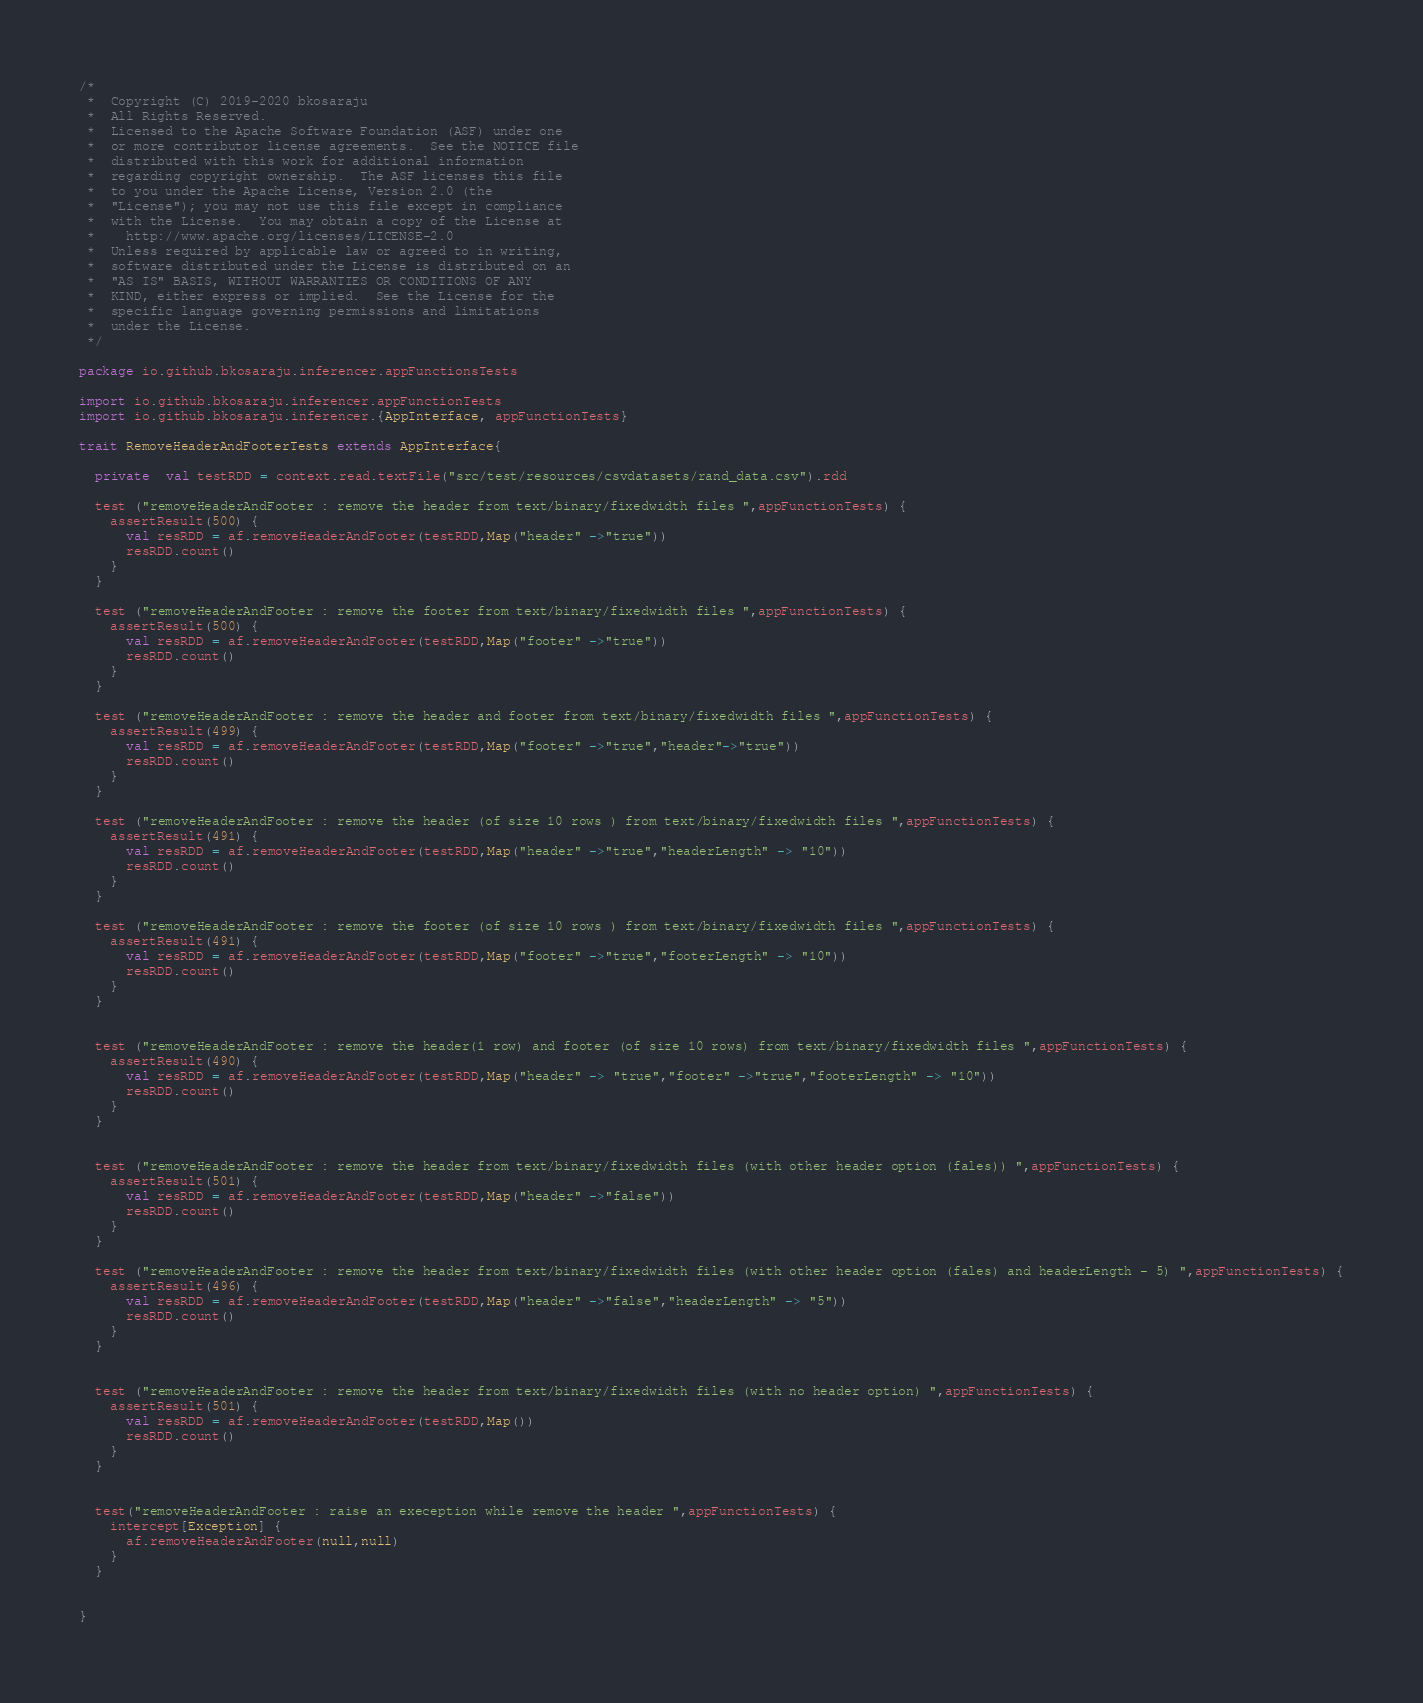<code> <loc_0><loc_0><loc_500><loc_500><_Scala_>/*
 *  Copyright (C) 2019-2020 bkosaraju
 *  All Rights Reserved.
 *  Licensed to the Apache Software Foundation (ASF) under one
 *  or more contributor license agreements.  See the NOTICE file
 *  distributed with this work for additional information
 *  regarding copyright ownership.  The ASF licenses this file
 *  to you under the Apache License, Version 2.0 (the
 *  "License"); you may not use this file except in compliance
 *  with the License.  You may obtain a copy of the License at
 *    http://www.apache.org/licenses/LICENSE-2.0
 *  Unless required by applicable law or agreed to in writing,
 *  software distributed under the License is distributed on an
 *  "AS IS" BASIS, WITHOUT WARRANTIES OR CONDITIONS OF ANY
 *  KIND, either express or implied.  See the License for the
 *  specific language governing permissions and limitations
 *  under the License.
 */

package io.github.bkosaraju.inferencer.appFunctionsTests

import io.github.bkosaraju.inferencer.appFunctionTests
import io.github.bkosaraju.inferencer.{AppInterface, appFunctionTests}

trait RemoveHeaderAndFooterTests extends AppInterface{

  private  val testRDD = context.read.textFile("src/test/resources/csvdatasets/rand_data.csv").rdd

  test ("removeHeaderAndFooter : remove the header from text/binary/fixedwidth files ",appFunctionTests) {
    assertResult(500) {
      val resRDD = af.removeHeaderAndFooter(testRDD,Map("header" ->"true"))
      resRDD.count()
    }
  }

  test ("removeHeaderAndFooter : remove the footer from text/binary/fixedwidth files ",appFunctionTests) {
    assertResult(500) {
      val resRDD = af.removeHeaderAndFooter(testRDD,Map("footer" ->"true"))
      resRDD.count()
    }
  }

  test ("removeHeaderAndFooter : remove the header and footer from text/binary/fixedwidth files ",appFunctionTests) {
    assertResult(499) {
      val resRDD = af.removeHeaderAndFooter(testRDD,Map("footer" ->"true","header"->"true"))
      resRDD.count()
    }
  }

  test ("removeHeaderAndFooter : remove the header (of size 10 rows ) from text/binary/fixedwidth files ",appFunctionTests) {
    assertResult(491) {
      val resRDD = af.removeHeaderAndFooter(testRDD,Map("header" ->"true","headerLength" -> "10"))
      resRDD.count()
    }
  }

  test ("removeHeaderAndFooter : remove the footer (of size 10 rows ) from text/binary/fixedwidth files ",appFunctionTests) {
    assertResult(491) {
      val resRDD = af.removeHeaderAndFooter(testRDD,Map("footer" ->"true","footerLength" -> "10"))
      resRDD.count()
    }
  }


  test ("removeHeaderAndFooter : remove the header(1 row) and footer (of size 10 rows) from text/binary/fixedwidth files ",appFunctionTests) {
    assertResult(490) {
      val resRDD = af.removeHeaderAndFooter(testRDD,Map("header" -> "true","footer" ->"true","footerLength" -> "10"))
      resRDD.count()
    }
  }


  test ("removeHeaderAndFooter : remove the header from text/binary/fixedwidth files (with other header option (fales)) ",appFunctionTests) {
    assertResult(501) {
      val resRDD = af.removeHeaderAndFooter(testRDD,Map("header" ->"false"))
      resRDD.count()
    }
  }

  test ("removeHeaderAndFooter : remove the header from text/binary/fixedwidth files (with other header option (fales) and headerLength - 5) ",appFunctionTests) {
    assertResult(496) {
      val resRDD = af.removeHeaderAndFooter(testRDD,Map("header" ->"false","headerLength" -> "5"))
      resRDD.count()
    }
  }


  test ("removeHeaderAndFooter : remove the header from text/binary/fixedwidth files (with no header option) ",appFunctionTests) {
    assertResult(501) {
      val resRDD = af.removeHeaderAndFooter(testRDD,Map())
      resRDD.count()
    }
  }


  test("removeHeaderAndFooter : raise an exeception while remove the header ",appFunctionTests) {
    intercept[Exception] {
      af.removeHeaderAndFooter(null,null)
    }
  }


}
</code> 